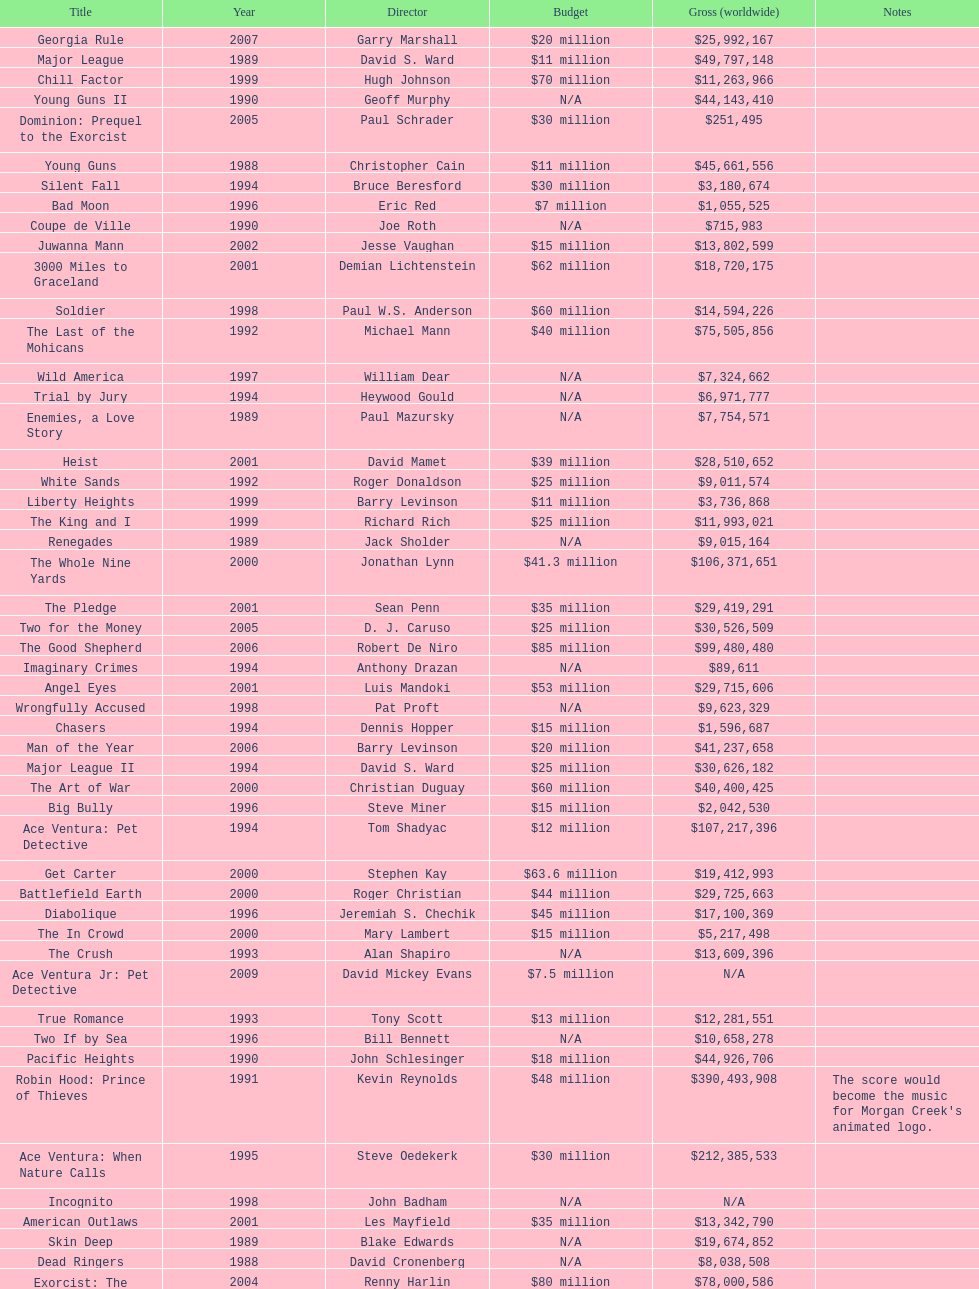After young guns, what was the next movie with the exact same budget? Major League. 